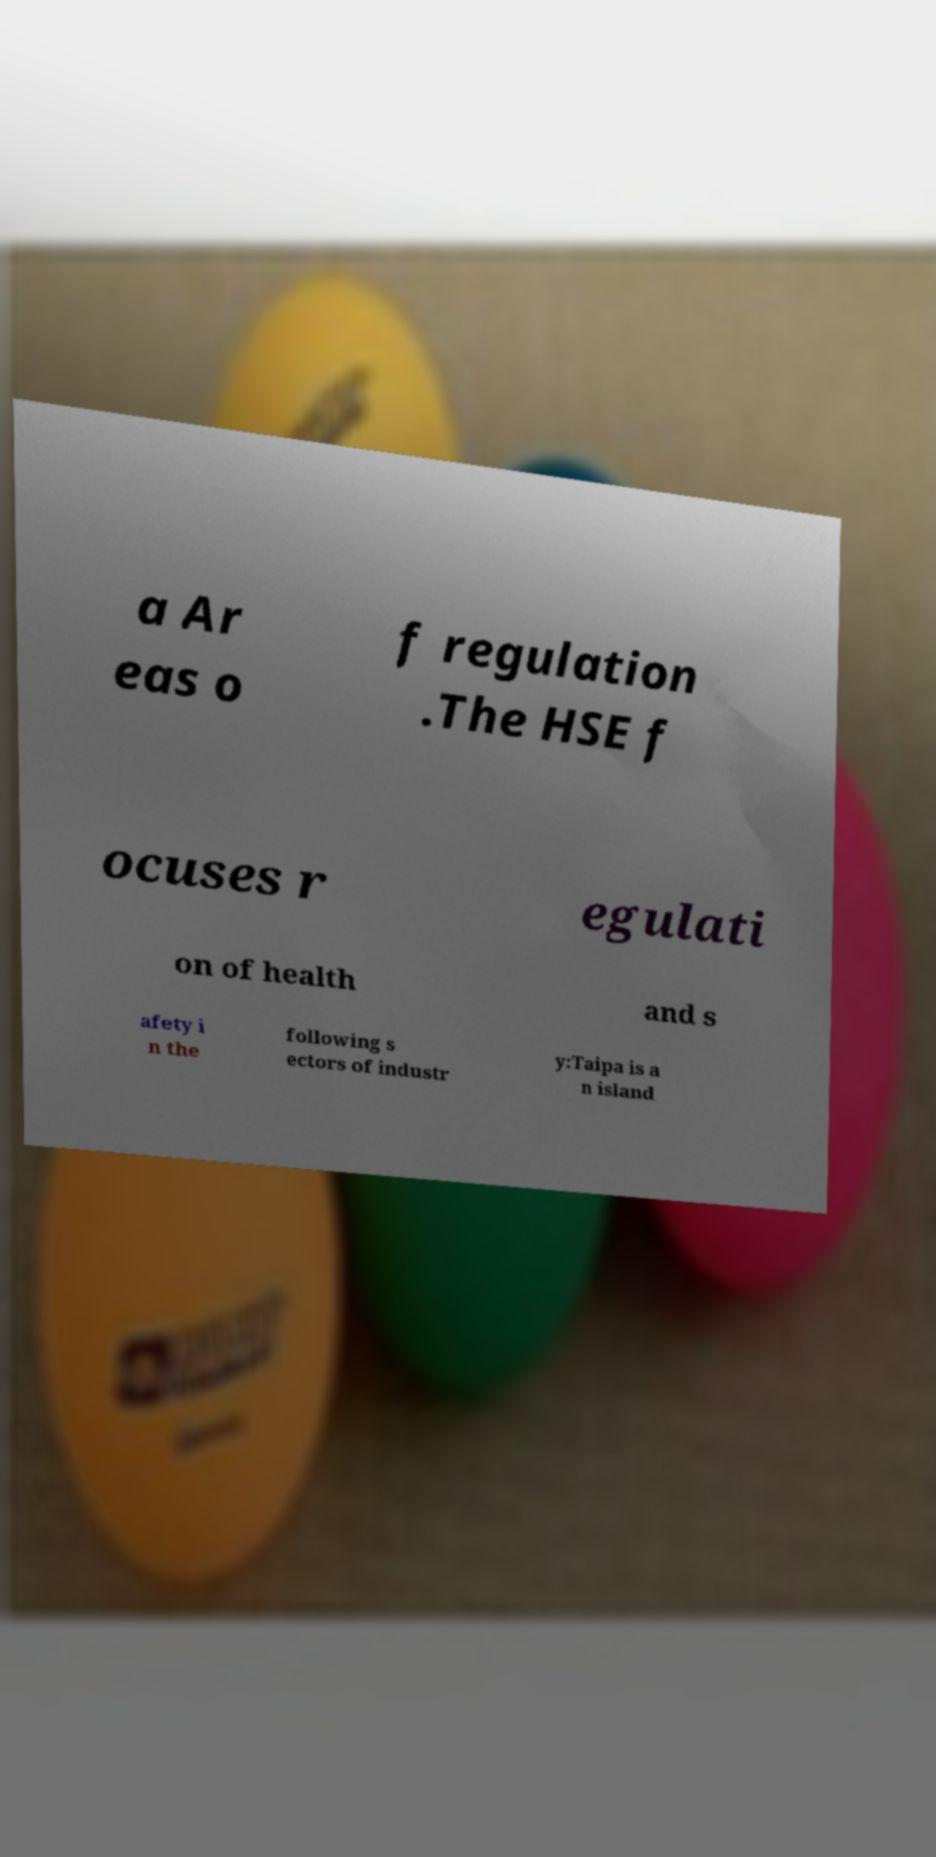What messages or text are displayed in this image? I need them in a readable, typed format. a Ar eas o f regulation .The HSE f ocuses r egulati on of health and s afety i n the following s ectors of industr y:Taipa is a n island 